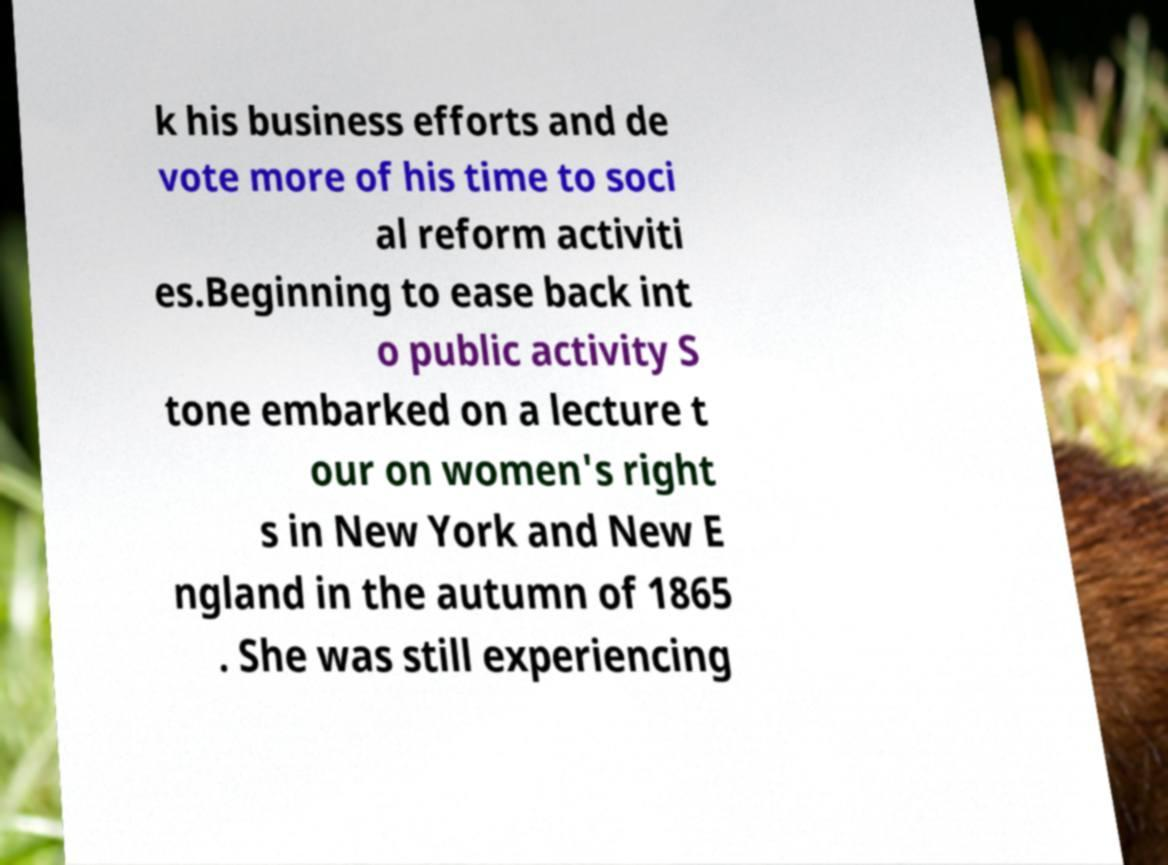What messages or text are displayed in this image? I need them in a readable, typed format. k his business efforts and de vote more of his time to soci al reform activiti es.Beginning to ease back int o public activity S tone embarked on a lecture t our on women's right s in New York and New E ngland in the autumn of 1865 . She was still experiencing 